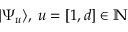Convert formula to latex. <formula><loc_0><loc_0><loc_500><loc_500>| \Psi _ { u } \rangle , \, u = [ 1 , d ] \in \mathbb { N }</formula> 